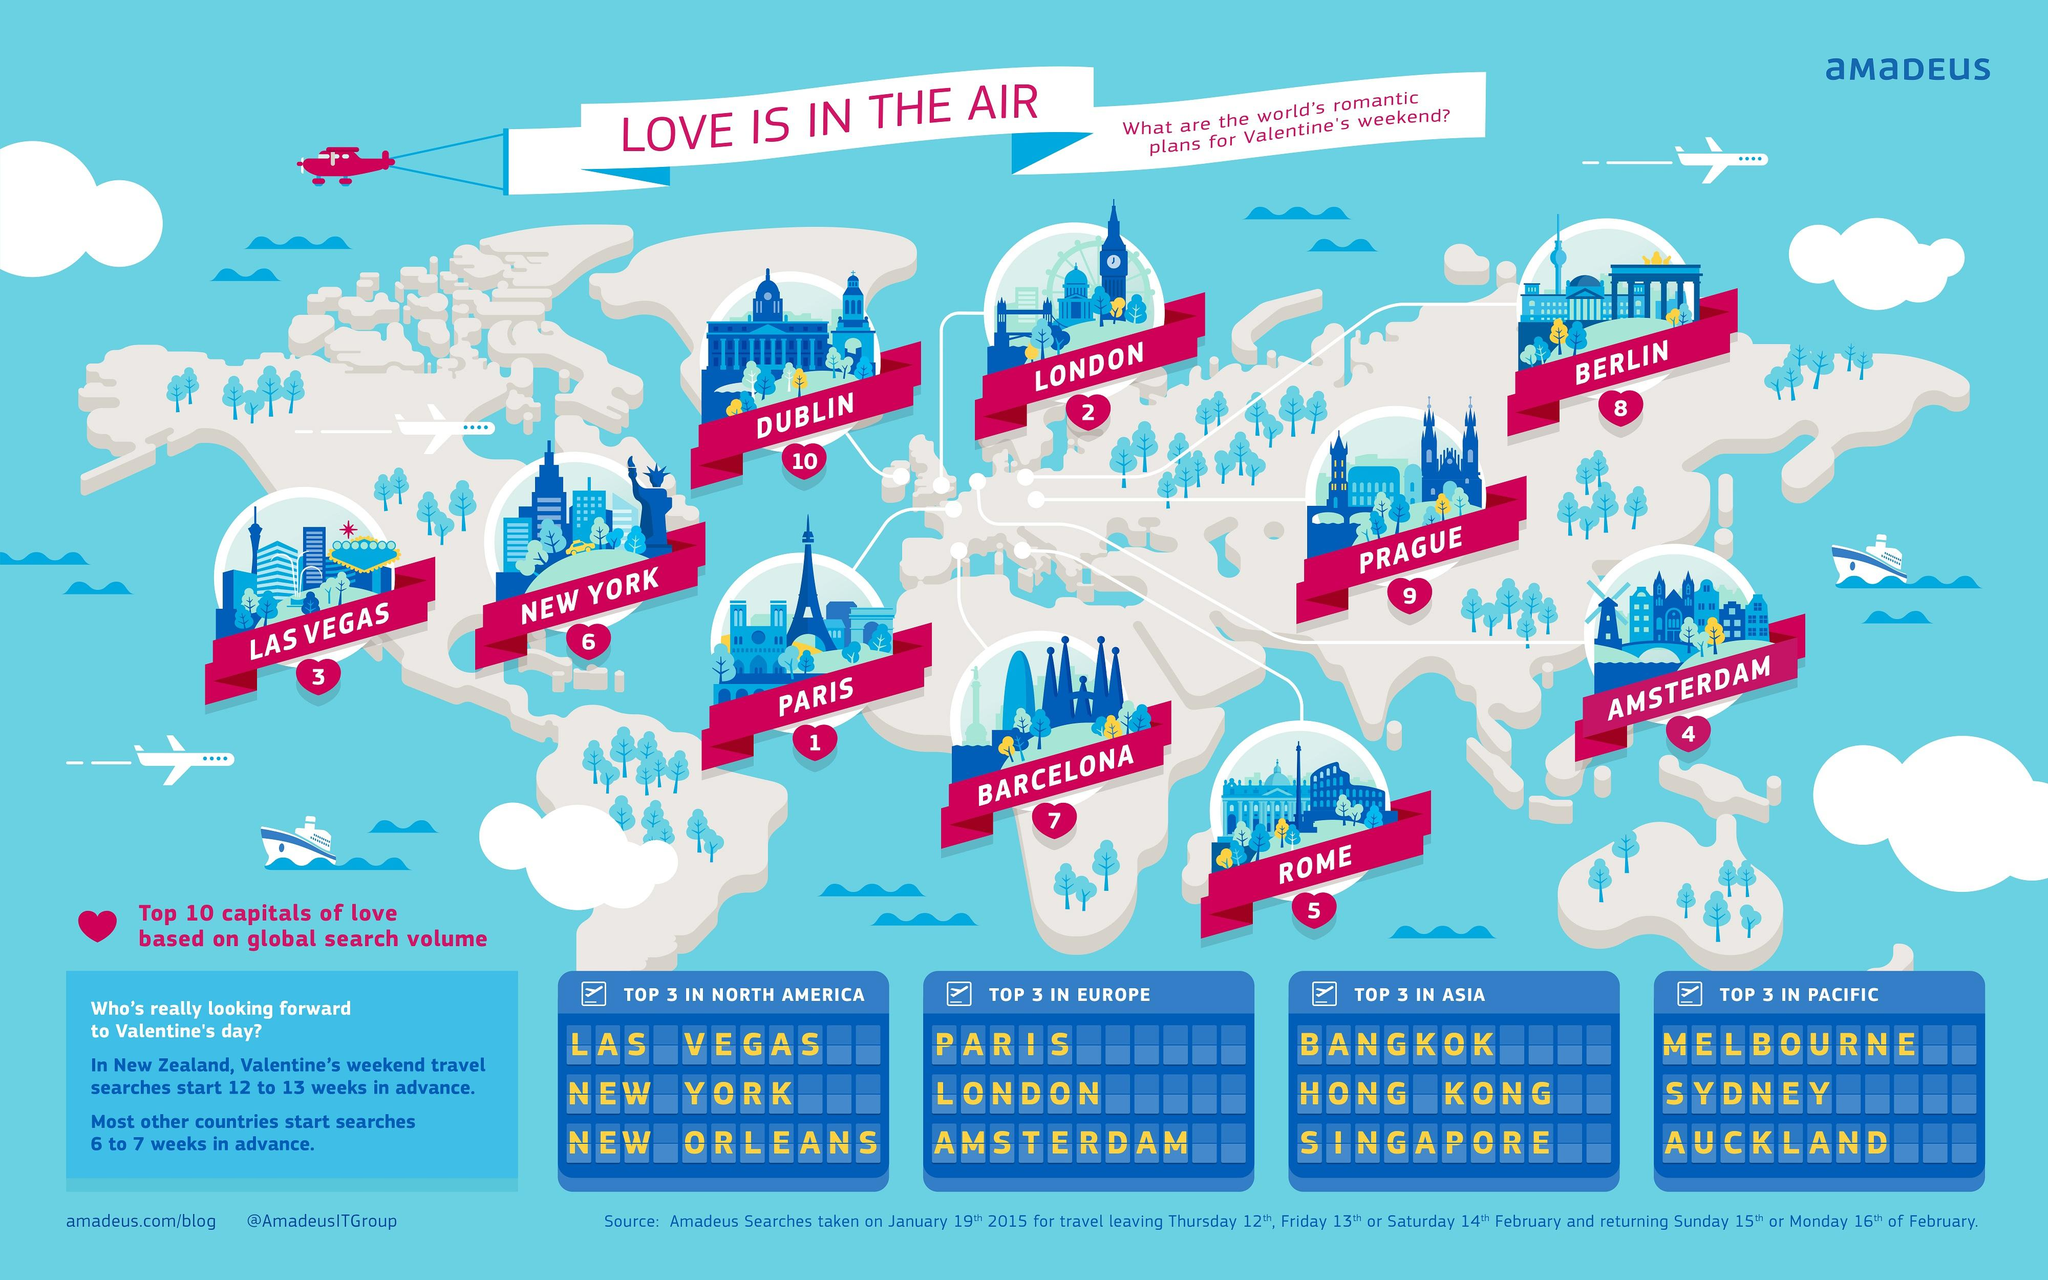Mention a couple of crucial points in this snapshot. The top three places to visit in Europe for a romantic Valentine's Day weekend are Paris, London, and Amsterdam. The majority of cities in the top ten ranking belong to Europe. The top three places to visit in Oceania for a romantic Valentine's Day weekend are Melbourne, Sydney, and Auckland, known for their stunning scenery, cultural attractions, and romantic experiences. There are two cities, Las Vegas and New York, that are located on the North American continent. 